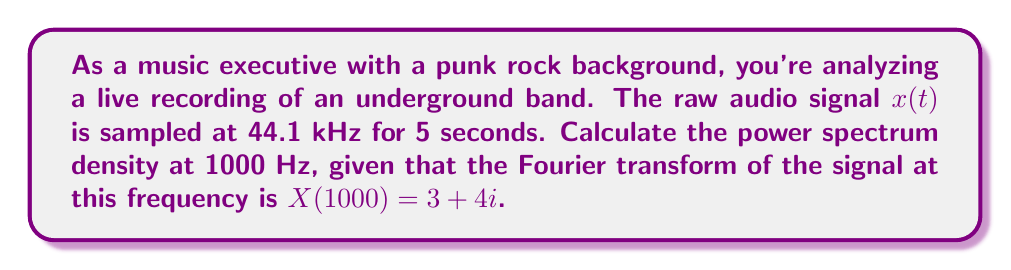Teach me how to tackle this problem. Let's approach this step-by-step:

1) The power spectrum density (PSD) is defined as the squared magnitude of the Fourier transform of the signal, divided by the total duration of the signal. In mathematical terms:

   $$S_{xx}(f) = \frac{|X(f)|^2}{T}$$

   where $S_{xx}(f)$ is the PSD, $X(f)$ is the Fourier transform, and $T$ is the duration of the signal.

2) We're given that $X(1000) = 3 + 4i$. To find $|X(1000)|^2$, we multiply this complex number by its conjugate:

   $$|X(1000)|^2 = (3 + 4i)(3 - 4i) = 3^2 + 4^2 = 9 + 16 = 25$$

3) The duration of the signal, $T$, is 5 seconds.

4) Now we can calculate the PSD at 1000 Hz:

   $$S_{xx}(1000) = \frac{|X(1000)|^2}{T} = \frac{25}{5} = 5$$

5) The units of PSD are power per Hz, which in this case would be $(\text{amplitude}^2)/\text{Hz}$.
Answer: $5 \, (\text{amplitude}^2)/\text{Hz}$ 